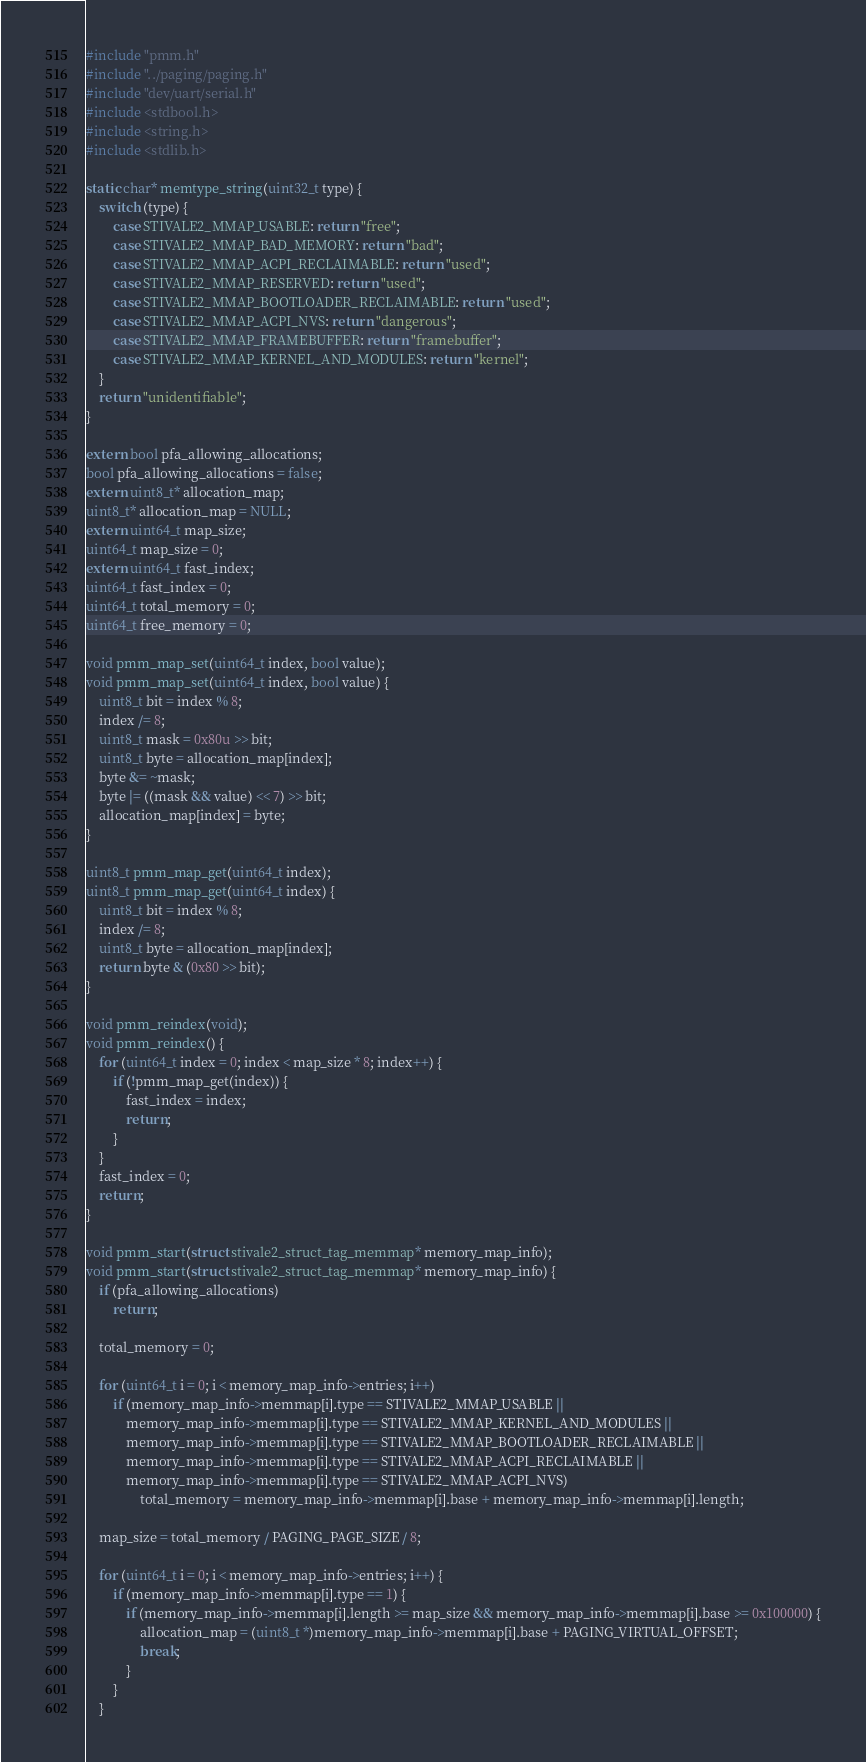Convert code to text. <code><loc_0><loc_0><loc_500><loc_500><_C_>#include "pmm.h"
#include "../paging/paging.h"
#include "dev/uart/serial.h"
#include <stdbool.h>
#include <string.h>
#include <stdlib.h>

static char* memtype_string(uint32_t type) {
    switch (type) {
        case STIVALE2_MMAP_USABLE: return "free";
        case STIVALE2_MMAP_BAD_MEMORY: return "bad";
        case STIVALE2_MMAP_ACPI_RECLAIMABLE: return "used";
        case STIVALE2_MMAP_RESERVED: return "used";
        case STIVALE2_MMAP_BOOTLOADER_RECLAIMABLE: return "used";
        case STIVALE2_MMAP_ACPI_NVS: return "dangerous";
        case STIVALE2_MMAP_FRAMEBUFFER: return "framebuffer";
        case STIVALE2_MMAP_KERNEL_AND_MODULES: return "kernel";
    }
    return "unidentifiable";
}

extern bool pfa_allowing_allocations;
bool pfa_allowing_allocations = false;
extern uint8_t* allocation_map;
uint8_t* allocation_map = NULL;
extern uint64_t map_size;
uint64_t map_size = 0;
extern uint64_t fast_index;
uint64_t fast_index = 0;
uint64_t total_memory = 0;
uint64_t free_memory = 0;

void pmm_map_set(uint64_t index, bool value);
void pmm_map_set(uint64_t index, bool value) {
    uint8_t bit = index % 8;
    index /= 8;
    uint8_t mask = 0x80u >> bit;
    uint8_t byte = allocation_map[index];
    byte &= ~mask;
    byte |= ((mask && value) << 7) >> bit;
    allocation_map[index] = byte;
}

uint8_t pmm_map_get(uint64_t index);
uint8_t pmm_map_get(uint64_t index) {
    uint8_t bit = index % 8;
    index /= 8;
    uint8_t byte = allocation_map[index];
    return byte & (0x80 >> bit);
}

void pmm_reindex(void);
void pmm_reindex() {
    for (uint64_t index = 0; index < map_size * 8; index++) {
        if (!pmm_map_get(index)) {
            fast_index = index;
            return;
        }
    }
    fast_index = 0;
    return;
}

void pmm_start(struct stivale2_struct_tag_memmap* memory_map_info);
void pmm_start(struct stivale2_struct_tag_memmap* memory_map_info) {
    if (pfa_allowing_allocations)
        return;

    total_memory = 0;

    for (uint64_t i = 0; i < memory_map_info->entries; i++)
        if (memory_map_info->memmap[i].type == STIVALE2_MMAP_USABLE ||
            memory_map_info->memmap[i].type == STIVALE2_MMAP_KERNEL_AND_MODULES ||
            memory_map_info->memmap[i].type == STIVALE2_MMAP_BOOTLOADER_RECLAIMABLE ||
            memory_map_info->memmap[i].type == STIVALE2_MMAP_ACPI_RECLAIMABLE ||
            memory_map_info->memmap[i].type == STIVALE2_MMAP_ACPI_NVS)
                total_memory = memory_map_info->memmap[i].base + memory_map_info->memmap[i].length;

    map_size = total_memory / PAGING_PAGE_SIZE / 8;

    for (uint64_t i = 0; i < memory_map_info->entries; i++) {
        if (memory_map_info->memmap[i].type == 1) {
            if (memory_map_info->memmap[i].length >= map_size && memory_map_info->memmap[i].base >= 0x100000) {
                allocation_map = (uint8_t *)memory_map_info->memmap[i].base + PAGING_VIRTUAL_OFFSET;
                break;
            }
        }
    }
</code> 